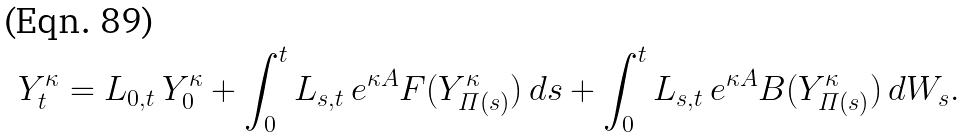Convert formula to latex. <formula><loc_0><loc_0><loc_500><loc_500>Y ^ { \kappa } _ { t } = L _ { 0 , t } \, Y ^ { \kappa } _ { 0 } + \int _ { 0 } ^ { t } L _ { s , t } \, e ^ { \kappa A } F ( Y ^ { \kappa } _ { \varPi ( s ) } ) \, d s + \int _ { 0 } ^ { t } L _ { s , t } \, e ^ { \kappa A } B ( Y ^ { \kappa } _ { \varPi ( s ) } ) \, d W _ { s } .</formula> 